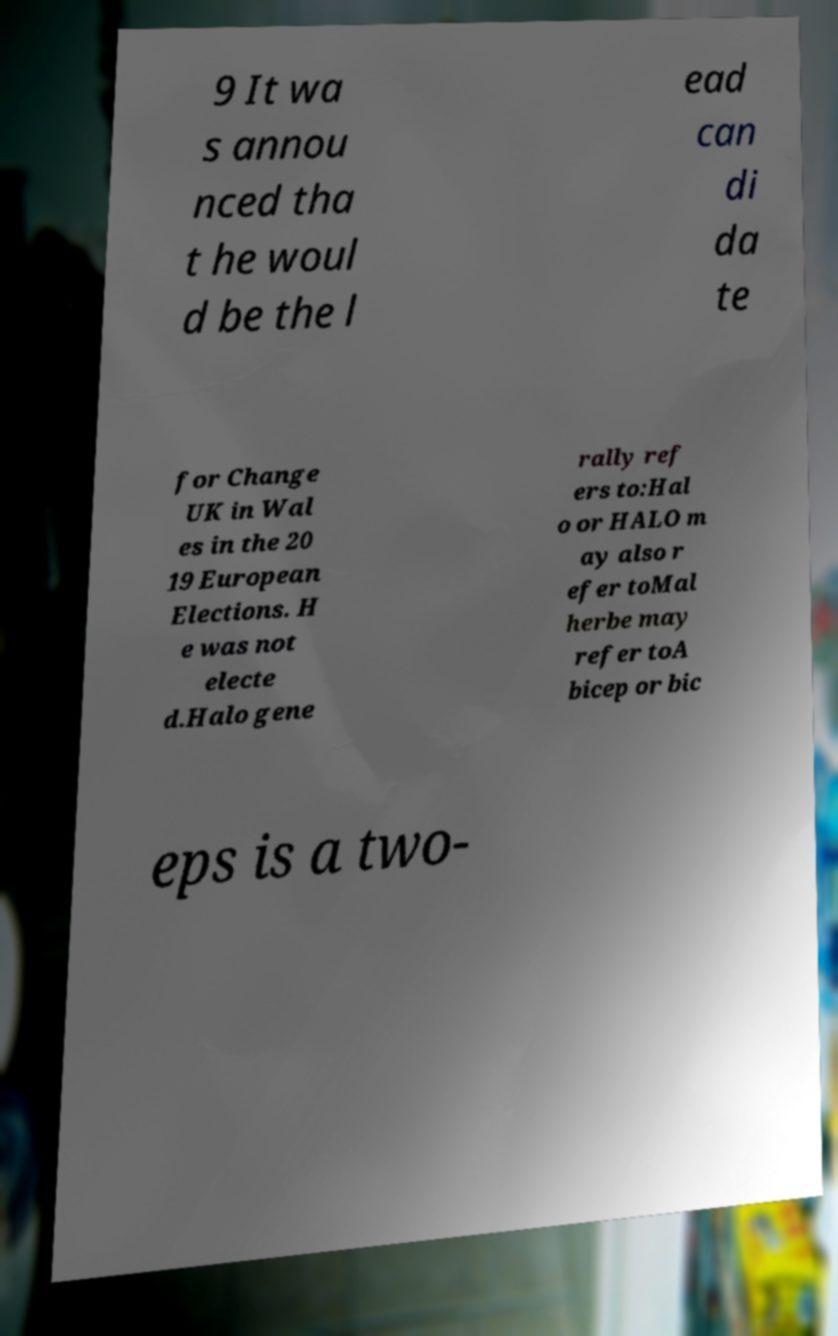Can you read and provide the text displayed in the image?This photo seems to have some interesting text. Can you extract and type it out for me? 9 It wa s annou nced tha t he woul d be the l ead can di da te for Change UK in Wal es in the 20 19 European Elections. H e was not electe d.Halo gene rally ref ers to:Hal o or HALO m ay also r efer toMal herbe may refer toA bicep or bic eps is a two- 